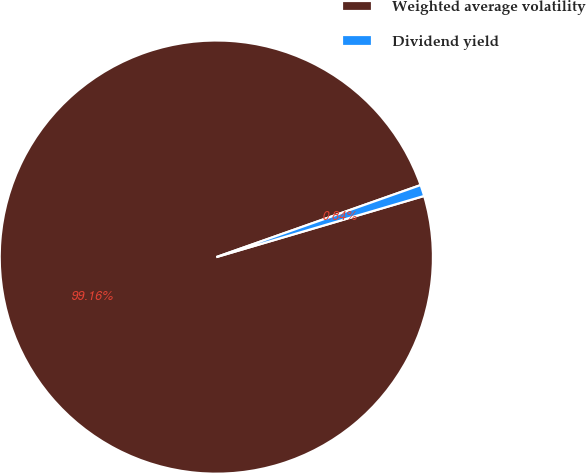Convert chart to OTSL. <chart><loc_0><loc_0><loc_500><loc_500><pie_chart><fcel>Weighted average volatility<fcel>Dividend yield<nl><fcel>99.16%<fcel>0.84%<nl></chart> 